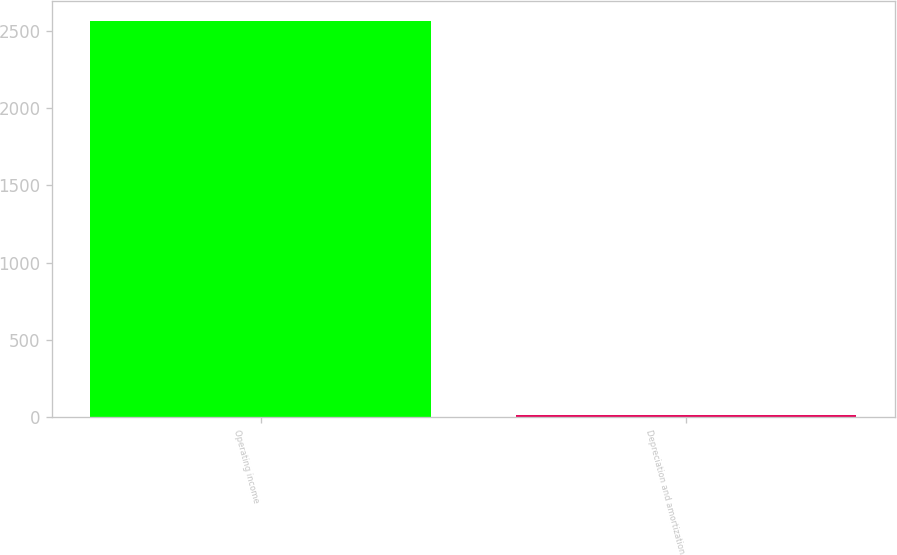Convert chart to OTSL. <chart><loc_0><loc_0><loc_500><loc_500><bar_chart><fcel>Operating income<fcel>Depreciation and amortization<nl><fcel>2563.9<fcel>15<nl></chart> 